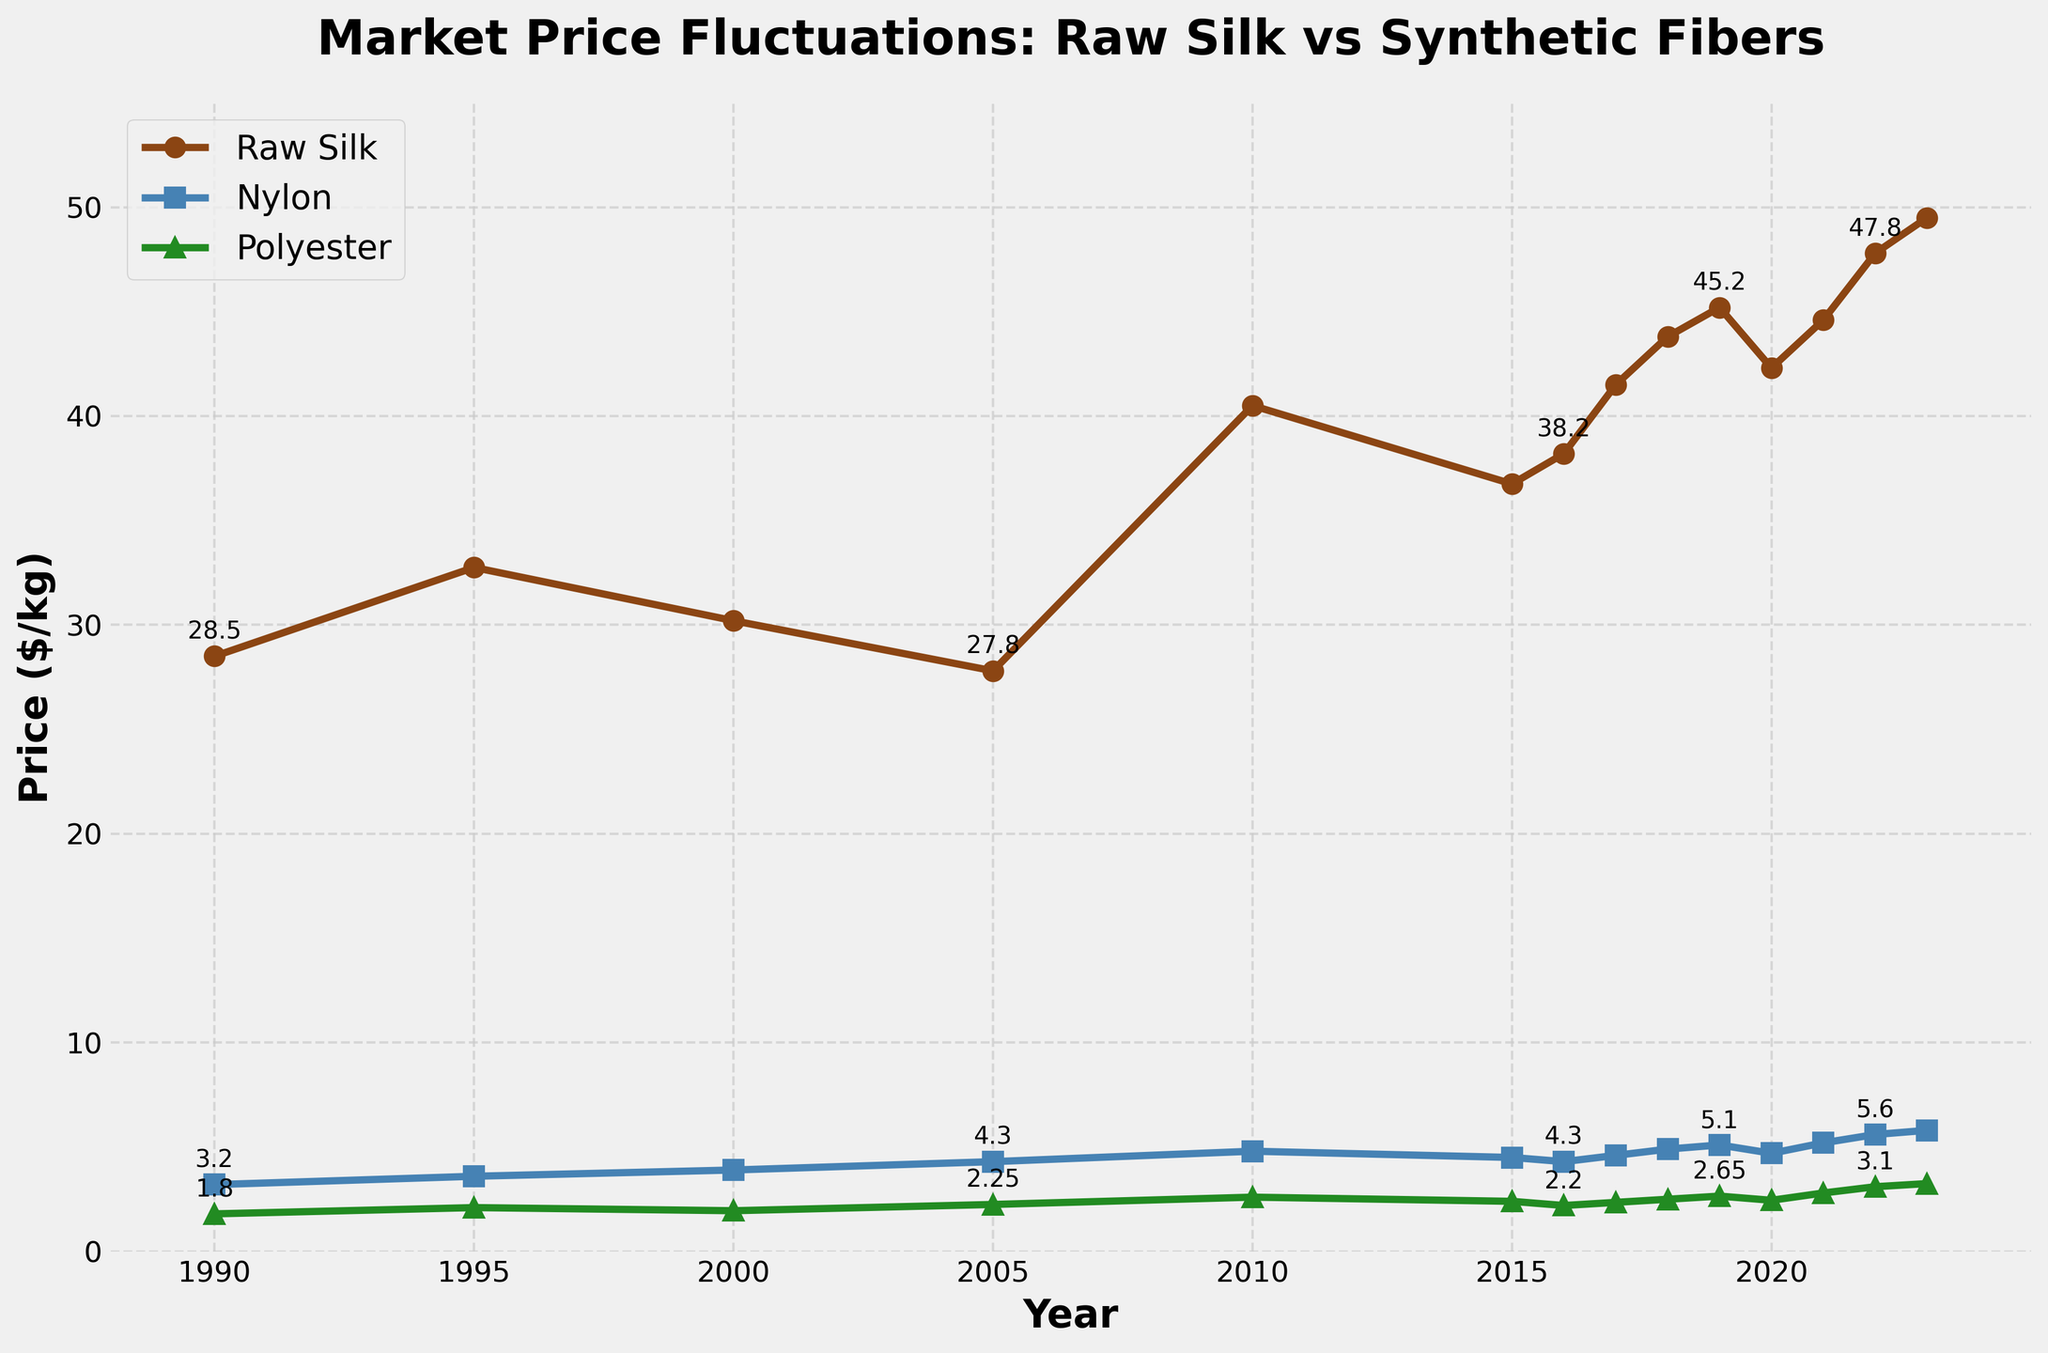What are the prices of raw silk, nylon, and polyester in 1990? To determine the prices in 1990, look at the values plotted at the year 1990 on the figure. Raw silk is marked with 'o', nylon with 's', and polyester with '^'.
Answer: Raw silk: $28.50/kg, Nylon: $3.20/kg, Polyester: $1.80/kg How does the price of raw silk in 2023 compare to nylon in 2020? Find the price of raw silk in 2023 and the price of nylon in 2020 from the plot. Compare these two values directly.
Answer: Raw silk is higher What is the average price of polyester over the entire period? Sum all the polyester prices across the years and divide by the number of years (14). Calculate: (1.80 + 2.10 + 1.95 + 2.25 + 2.60 + 2.40 + 2.20 + 2.35 + 2.50 + 2.65 + 2.45 + 2.80 + 3.10 + 3.25) / 14 ≈ 2.48.
Answer: $2.48/kg Which year did nylon have the highest price and what was the price? Look for the peak value of the nylon (marked with 's' and blue color) on the plot. The highest price is in 2023.
Answer: 2023, $5.80/kg In which year did raw silk experience the biggest price drop? Observe the year-to-year changes for raw silk. The largest drop appears to be from 2019 to 2020.
Answer: 2019 to 2020 What is the difference in price between raw silk and polyester in 2022? Find the prices for raw silk and polyester in 2022 on the plot and compute the difference: $47.80 - $3.10 = $44.70.
Answer: $44.70/kg How did the price of raw silk change from 2010 to 2023? Look at the prices of raw silk in 2010 and 2023, and determine the change: $49.50 - $40.50 = $9.00.
Answer: Increased by $9.00/kg Compare the price trends of raw silk and synthetic fibers (nylon and polyester) between 1990 and 2023. Observe the slopes of the lines representing each material. Raw silk shows significant volatility and an overall increase, while synthetic fibers have a steadier, more gradual increase.
Answer: Raw silk is more volatile; synthetic fibers' prices increase steadily What is the overall trend for polyester prices from 1990 to 2023? Look at the general direction and slope of the polyester line. It shows a gradual upward trend.
Answer: Gradual upward trend 